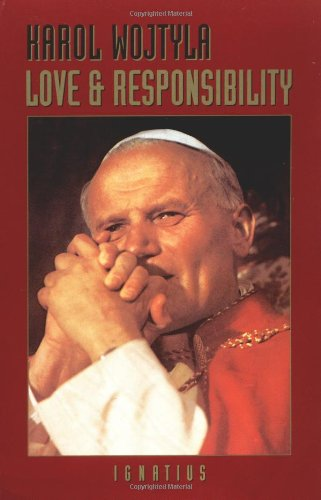Is this a motivational book? This book is not typically categorized as motivational. It delves into ethical theory and personal responsibility within relationships, grounded in a deep theological framework. 